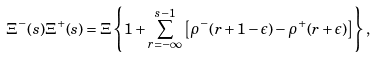Convert formula to latex. <formula><loc_0><loc_0><loc_500><loc_500>\Xi ^ { - } ( s ) \Xi ^ { + } ( s ) = \Xi \left \{ 1 + \sum _ { r = - \infty } ^ { s - 1 } \left [ \rho ^ { - } ( r + 1 - \epsilon ) - \rho ^ { + } ( r + \epsilon ) \right ] \right \} ,</formula> 